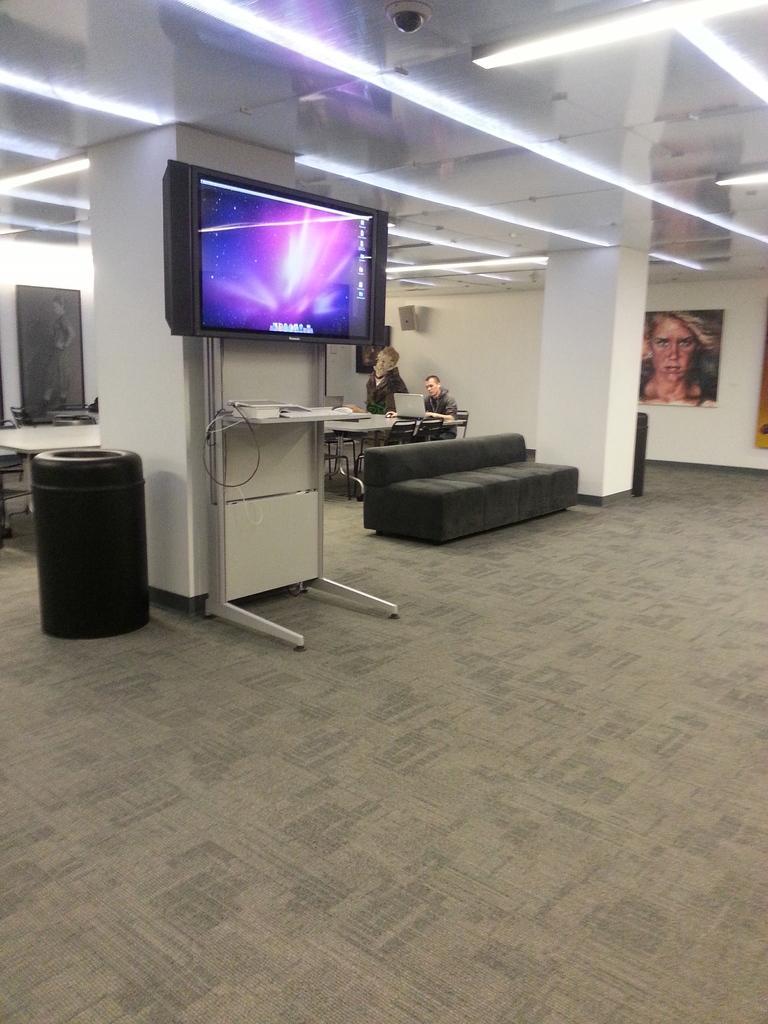How would you summarize this image in a sentence or two? This picture is clicked inside the room. Here, we see a television which is placed on the pillar. Beside that, we see a sofa and behind that, we see a man sitting on chair and working on laptop which is placed on a table and on background, we see a wall which is white in color and a photo frame is placed on the wall. On top of the picture, we see the ceiling of that room. 